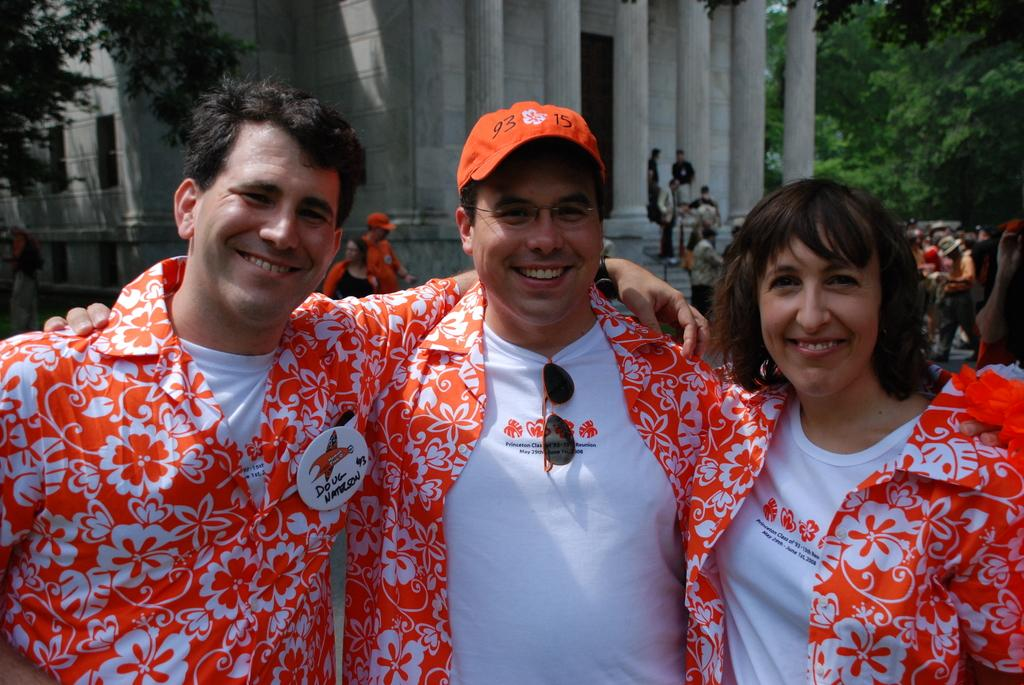How many people are standing in the foreground of the image? There are three people standing in the foreground of the image. What can be seen in the background of the image? There are buildings, trees, and pillars in the background of the image. Are there any other people visible in the image besides the three in the foreground? Yes, there are other people visible in the image. What type of cakes are being served to the people in the image? There is no mention of cakes or any food items in the image. What level of pleasure can be observed on the faces of the people in the image? The image does not provide information about the emotions or expressions of the people, so it is impossible to determine their level of pleasure. 